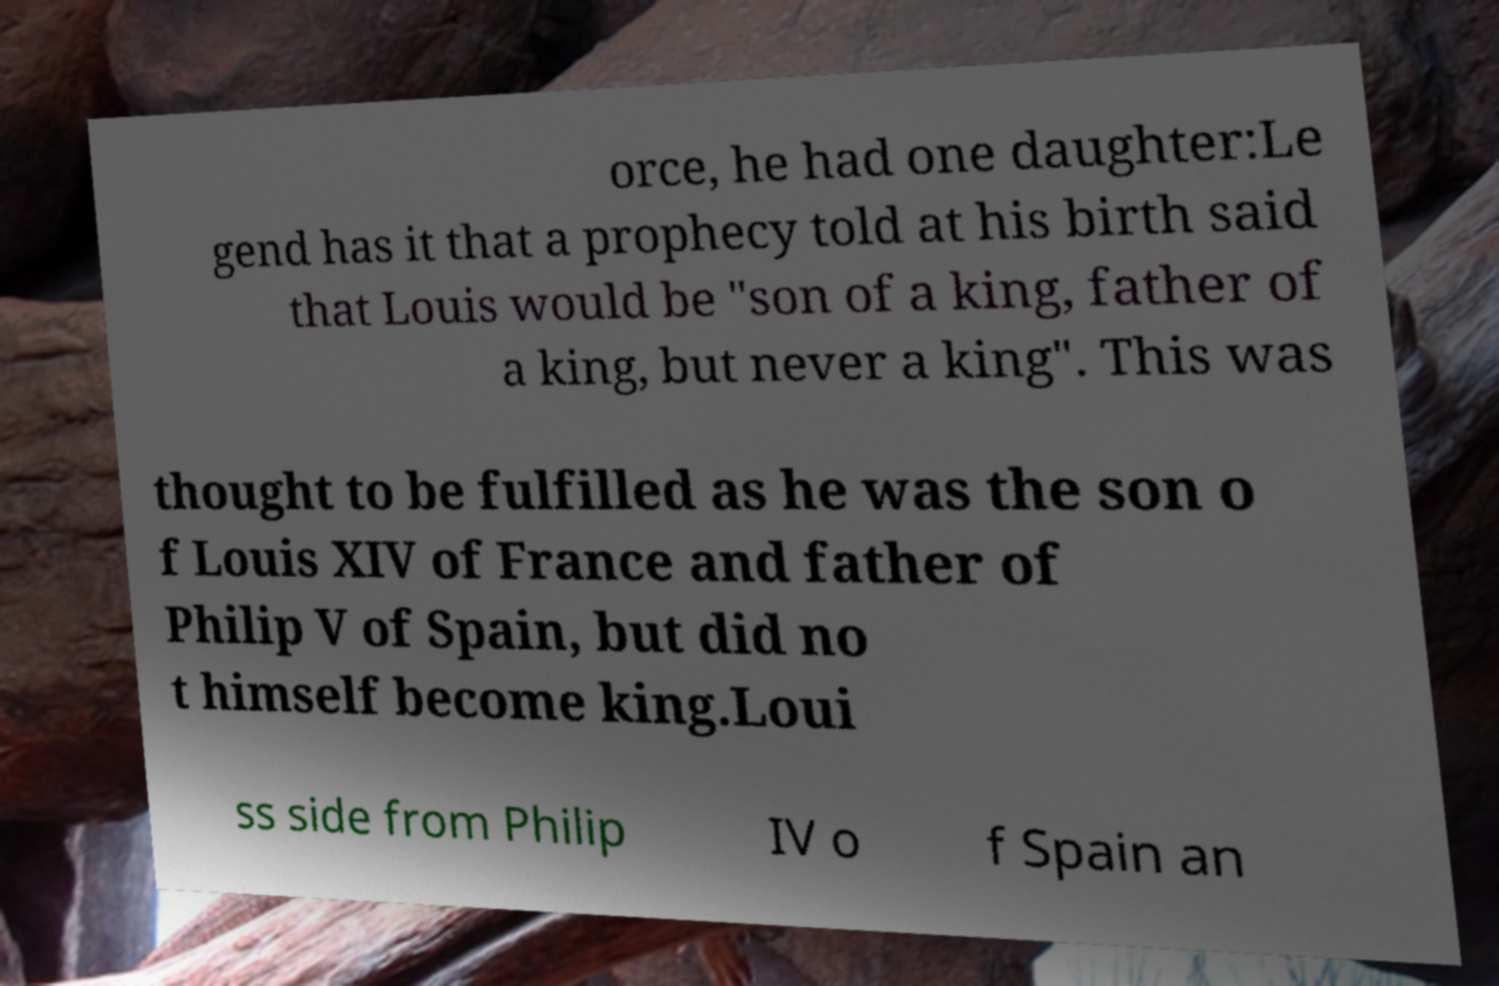Please read and relay the text visible in this image. What does it say? orce, he had one daughter:Le gend has it that a prophecy told at his birth said that Louis would be "son of a king, father of a king, but never a king". This was thought to be fulfilled as he was the son o f Louis XIV of France and father of Philip V of Spain, but did no t himself become king.Loui ss side from Philip IV o f Spain an 